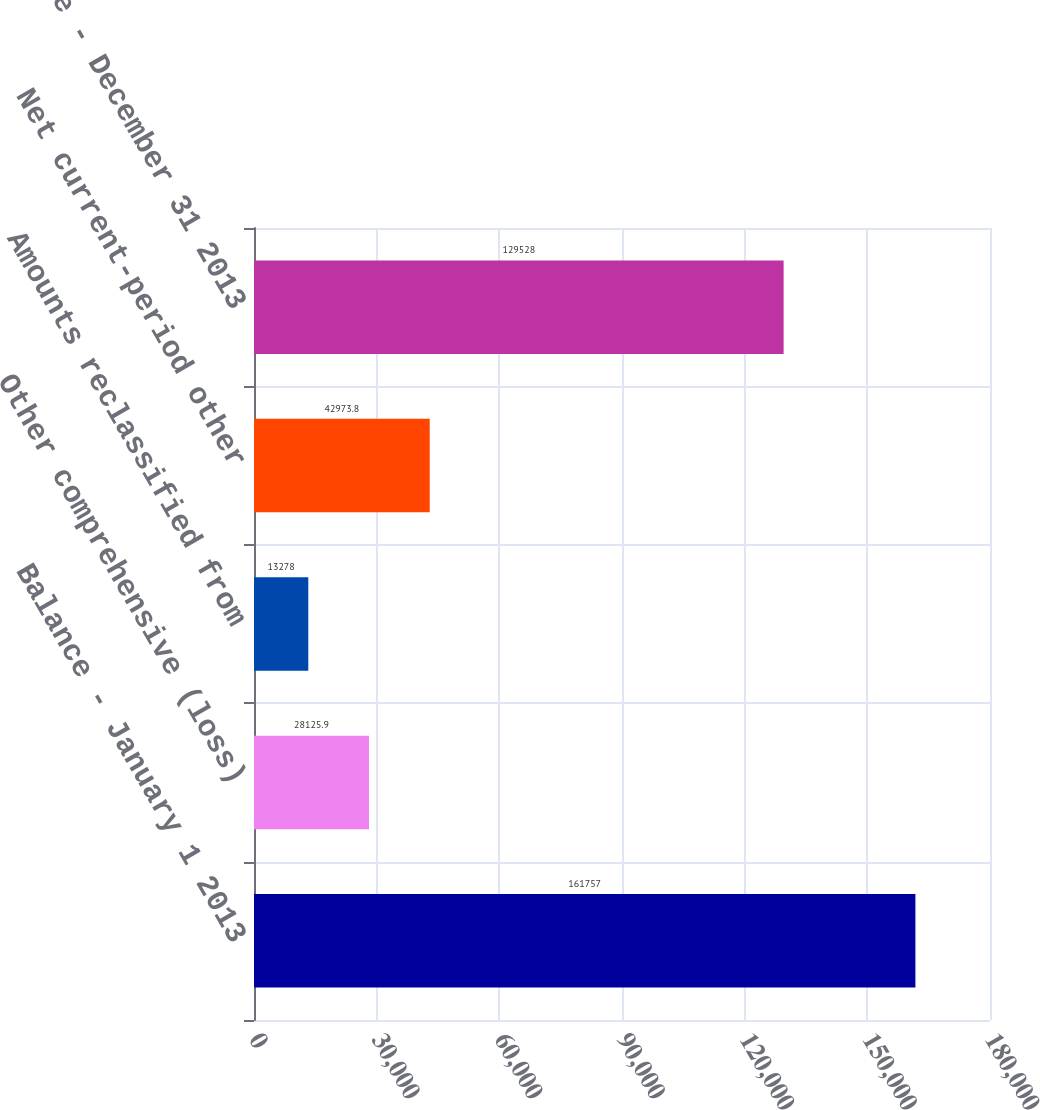Convert chart. <chart><loc_0><loc_0><loc_500><loc_500><bar_chart><fcel>Balance - January 1 2013<fcel>Other comprehensive (loss)<fcel>Amounts reclassified from<fcel>Net current-period other<fcel>Balance - December 31 2013<nl><fcel>161757<fcel>28125.9<fcel>13278<fcel>42973.8<fcel>129528<nl></chart> 